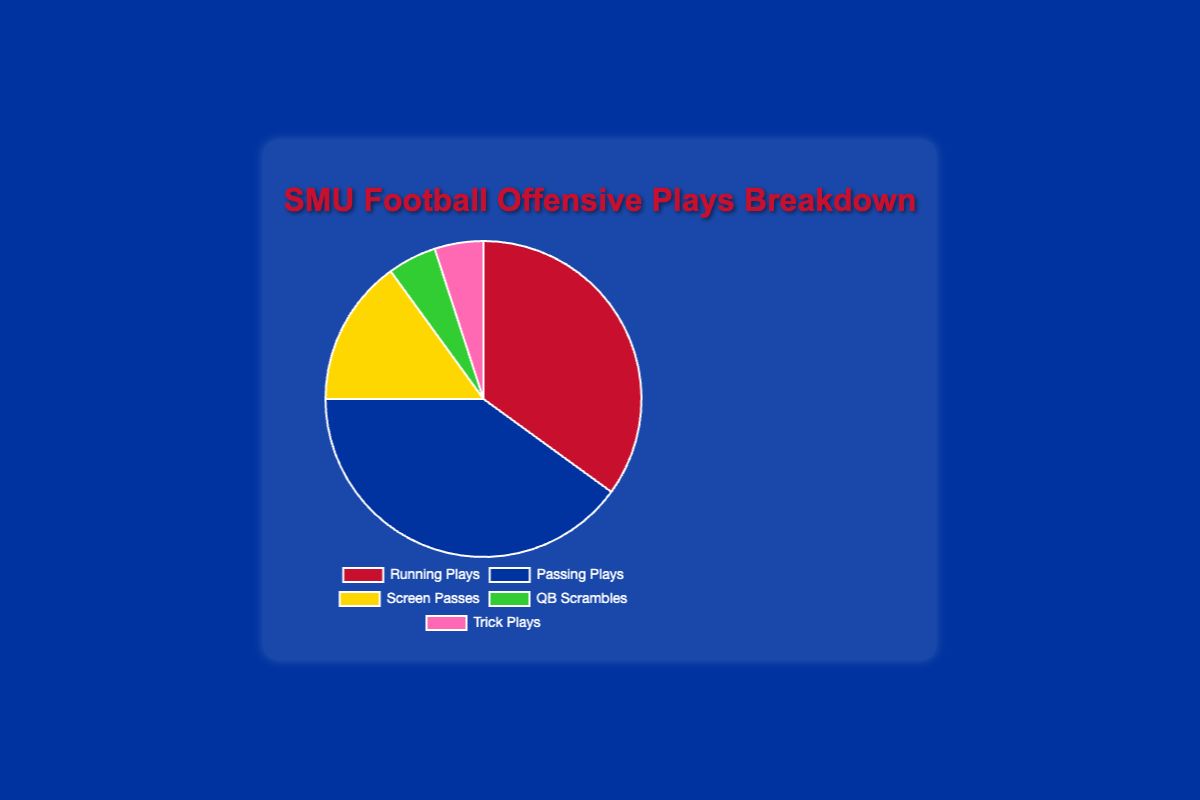Which type of play constitutes the largest percentage of SMU's offensive plays? By looking at the pie chart, we can see that the segment representing Passing Plays is the largest. Thus, Passing Plays constitute the largest percentage of SMU's offensive plays.
Answer: Passing Plays What is the combined percentage of Running Plays and Passing Plays? The chart shows that Running Plays make up 35% and Passing Plays make up 40%. Adding these together, we get 35% + 40% = 75%.
Answer: 75% How much larger is the percentage of Passing Plays compared to Trick Plays? The percentage for Passing Plays is 40%, and for Trick Plays, it's 5%. The difference is calculated as 40% - 5% = 35%.
Answer: 35% Which types of plays make up equal percentages of the offensive plays? According to the pie chart, both QB Scrambles and Trick Plays make up 5% each of the offensive plays.
Answer: QB Scrambles and Trick Plays Rank the play types by their percentage from highest to lowest. From the pie chart, we can see that the percentages for each play type are as follows: Passing Plays (40%), Running Plays (35%), Screen Passes (15%), QB Scrambles (5%), and Trick Plays (5%). Ranking them from highest to lowest gives us: Passing Plays, Running Plays, Screen Passes, QB Scrambles/Trick Plays.
Answer: Passing Plays, Running Plays, Screen Passes, QB Scrambles/Trick Plays What is the percentage difference between Screen Passes and Running Plays? Screen Passes make up 15% of the offensive plays, while Running Plays make up 35%. The difference in percentage is calculated as 35% - 15% = 20%.
Answer: 20% What color represents the Running Plays in the pie chart? By looking at the colors in the pie chart, we see that the segment for Running Plays is represented in red.
Answer: Red If the percentage of Passing Plays were reduced by half, what would the new percentage be? The current percentage of Passing Plays is 40%. Reducing this by half gives us 40% / 2 = 20%.
Answer: 20% 